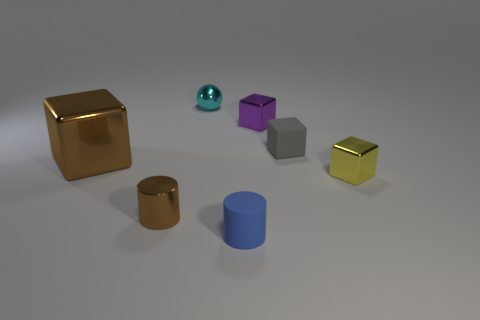Add 2 tiny brown spheres. How many objects exist? 9 Subtract all big metallic cubes. How many cubes are left? 3 Subtract all cylinders. How many objects are left? 5 Subtract all purple cubes. How many cubes are left? 3 Subtract all red spheres. Subtract all blue cubes. How many spheres are left? 1 Subtract all cyan balls. Subtract all blue matte things. How many objects are left? 5 Add 2 tiny metallic things. How many tiny metallic things are left? 6 Add 2 brown shiny cubes. How many brown shiny cubes exist? 3 Subtract 0 yellow cylinders. How many objects are left? 7 Subtract 4 blocks. How many blocks are left? 0 